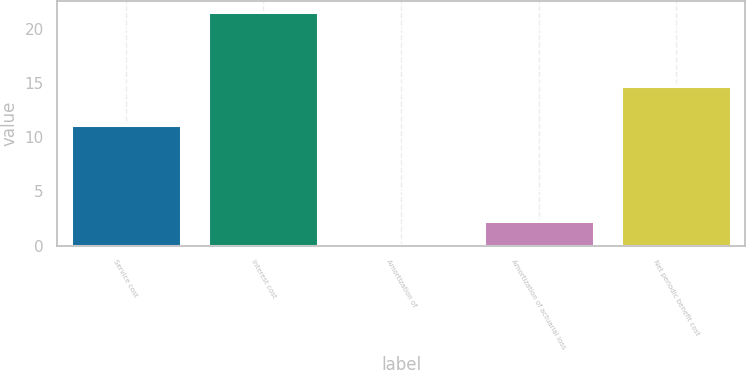Convert chart. <chart><loc_0><loc_0><loc_500><loc_500><bar_chart><fcel>Service cost<fcel>Interest cost<fcel>Amortization of<fcel>Amortization of actuarial loss<fcel>Net periodic benefit cost<nl><fcel>11.1<fcel>21.5<fcel>0.1<fcel>2.24<fcel>14.7<nl></chart> 